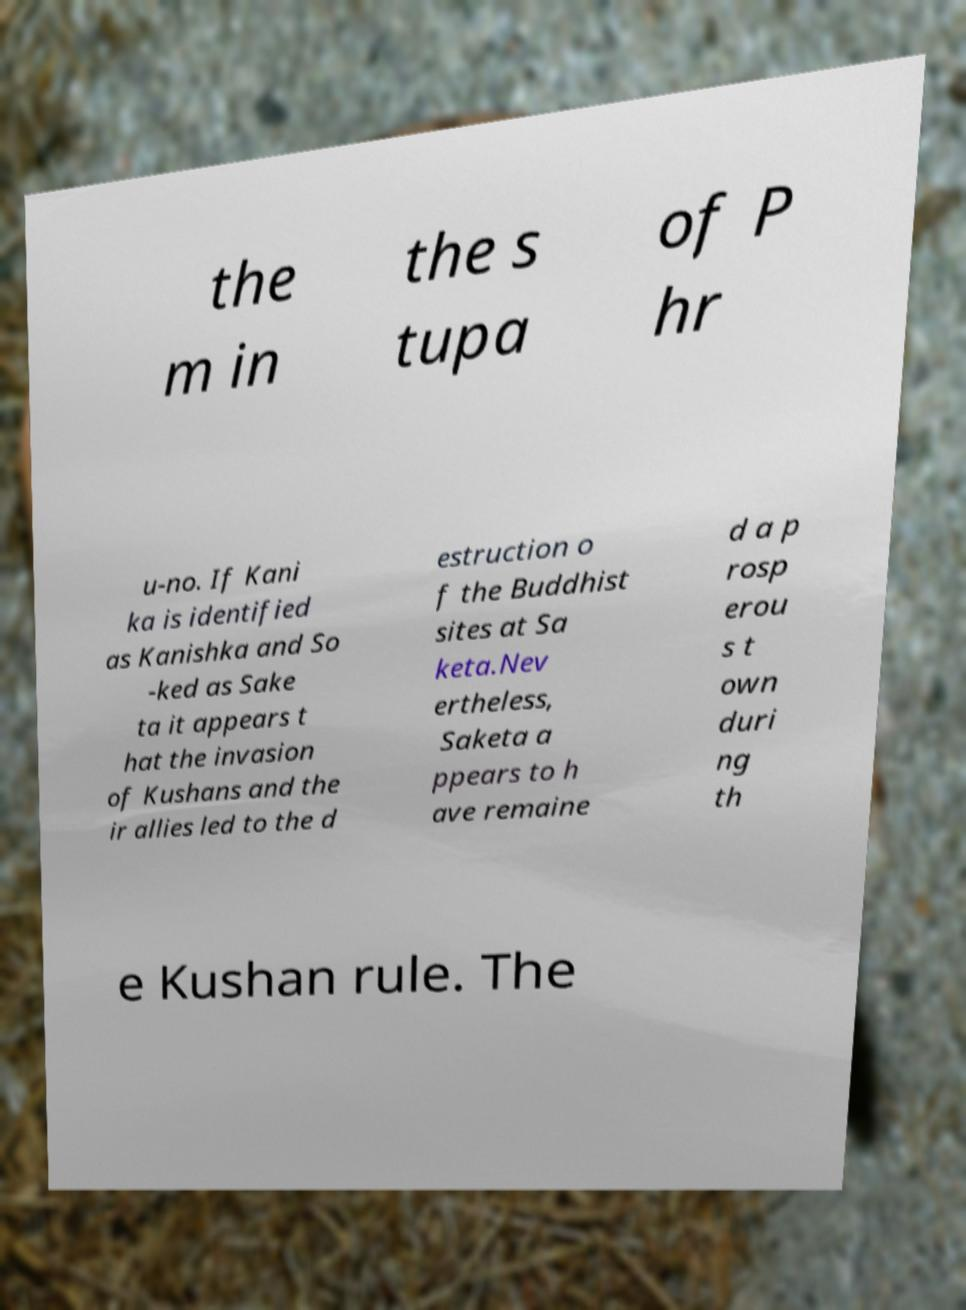Could you assist in decoding the text presented in this image and type it out clearly? the m in the s tupa of P hr u-no. If Kani ka is identified as Kanishka and So -ked as Sake ta it appears t hat the invasion of Kushans and the ir allies led to the d estruction o f the Buddhist sites at Sa keta.Nev ertheless, Saketa a ppears to h ave remaine d a p rosp erou s t own duri ng th e Kushan rule. The 